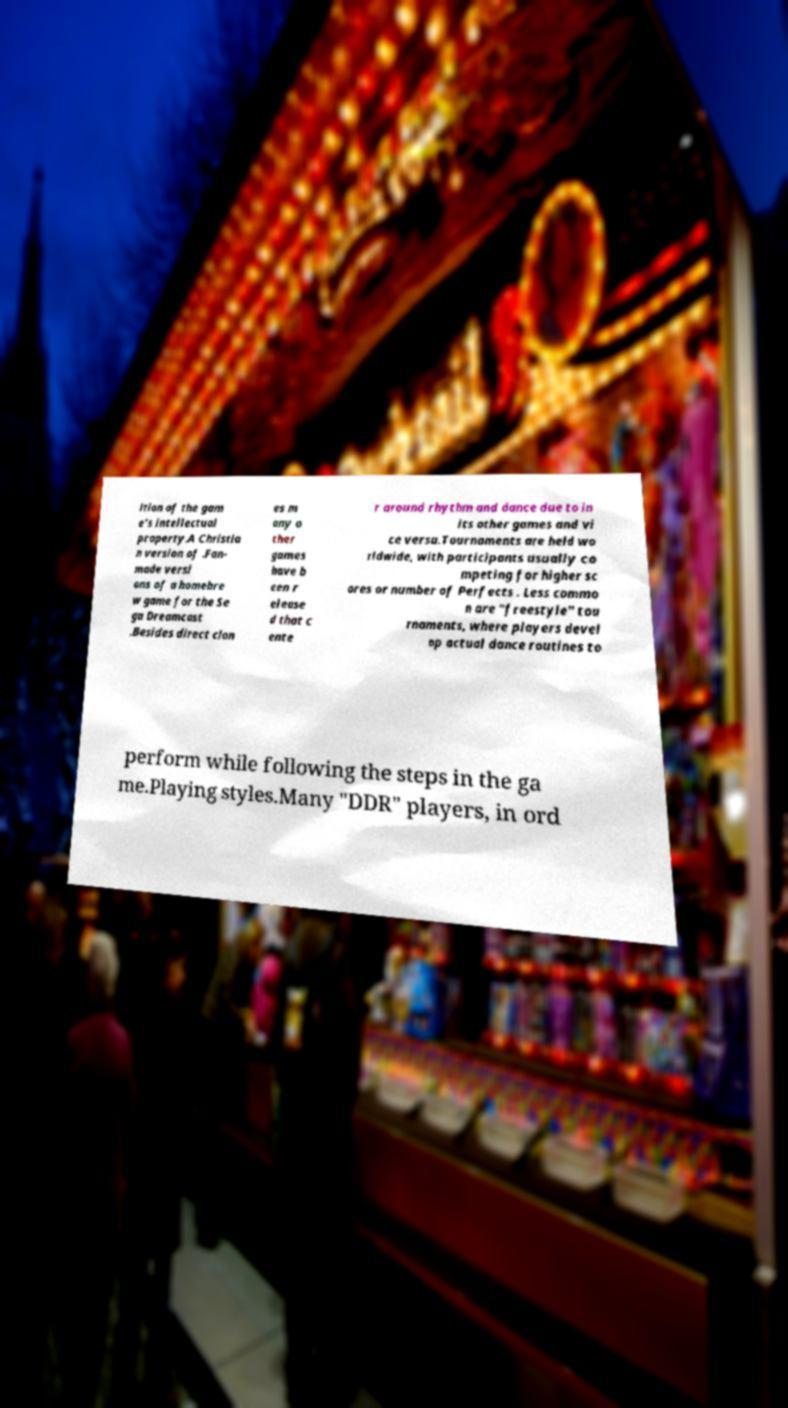Please read and relay the text visible in this image. What does it say? ition of the gam e's intellectual property.A Christia n version of .Fan- made versi ons of a homebre w game for the Se ga Dreamcast .Besides direct clon es m any o ther games have b een r elease d that c ente r around rhythm and dance due to in its other games and vi ce versa.Tournaments are held wo rldwide, with participants usually co mpeting for higher sc ores or number of Perfects . Less commo n are "freestyle" tou rnaments, where players devel op actual dance routines to perform while following the steps in the ga me.Playing styles.Many "DDR" players, in ord 